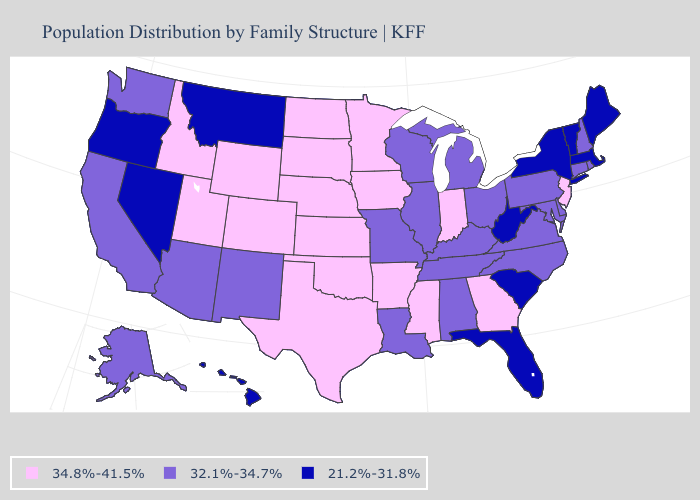Name the states that have a value in the range 34.8%-41.5%?
Answer briefly. Arkansas, Colorado, Georgia, Idaho, Indiana, Iowa, Kansas, Minnesota, Mississippi, Nebraska, New Jersey, North Dakota, Oklahoma, South Dakota, Texas, Utah, Wyoming. Name the states that have a value in the range 32.1%-34.7%?
Be succinct. Alabama, Alaska, Arizona, California, Connecticut, Delaware, Illinois, Kentucky, Louisiana, Maryland, Michigan, Missouri, New Hampshire, New Mexico, North Carolina, Ohio, Pennsylvania, Rhode Island, Tennessee, Virginia, Washington, Wisconsin. What is the highest value in the South ?
Be succinct. 34.8%-41.5%. What is the value of Maryland?
Short answer required. 32.1%-34.7%. Among the states that border Illinois , which have the highest value?
Be succinct. Indiana, Iowa. What is the lowest value in states that border Illinois?
Concise answer only. 32.1%-34.7%. Among the states that border Ohio , does Pennsylvania have the lowest value?
Keep it brief. No. Is the legend a continuous bar?
Keep it brief. No. How many symbols are there in the legend?
Concise answer only. 3. What is the value of Kentucky?
Write a very short answer. 32.1%-34.7%. What is the highest value in the USA?
Give a very brief answer. 34.8%-41.5%. Among the states that border Nevada , which have the lowest value?
Concise answer only. Oregon. Name the states that have a value in the range 32.1%-34.7%?
Concise answer only. Alabama, Alaska, Arizona, California, Connecticut, Delaware, Illinois, Kentucky, Louisiana, Maryland, Michigan, Missouri, New Hampshire, New Mexico, North Carolina, Ohio, Pennsylvania, Rhode Island, Tennessee, Virginia, Washington, Wisconsin. Does Michigan have the lowest value in the MidWest?
Be succinct. Yes. What is the lowest value in the MidWest?
Write a very short answer. 32.1%-34.7%. 